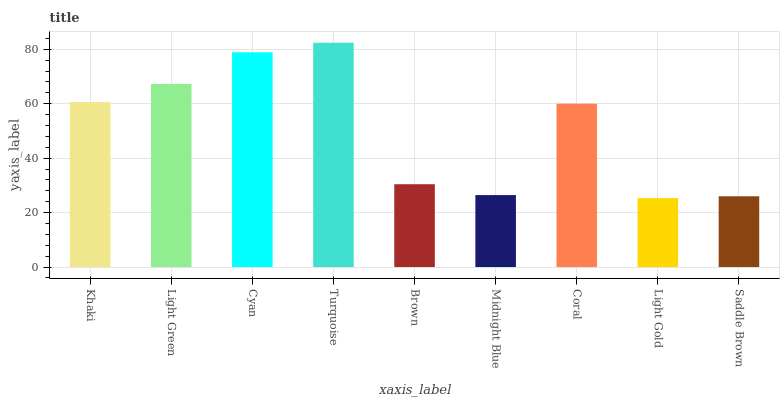Is Light Gold the minimum?
Answer yes or no. Yes. Is Turquoise the maximum?
Answer yes or no. Yes. Is Light Green the minimum?
Answer yes or no. No. Is Light Green the maximum?
Answer yes or no. No. Is Light Green greater than Khaki?
Answer yes or no. Yes. Is Khaki less than Light Green?
Answer yes or no. Yes. Is Khaki greater than Light Green?
Answer yes or no. No. Is Light Green less than Khaki?
Answer yes or no. No. Is Coral the high median?
Answer yes or no. Yes. Is Coral the low median?
Answer yes or no. Yes. Is Turquoise the high median?
Answer yes or no. No. Is Midnight Blue the low median?
Answer yes or no. No. 